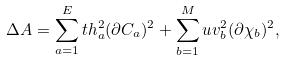Convert formula to latex. <formula><loc_0><loc_0><loc_500><loc_500>\Delta A = \sum _ { a = 1 } ^ { E } t h _ { a } ^ { 2 } ( \partial C _ { a } ) ^ { 2 } + \sum _ { b = 1 } ^ { M } u v _ { b } ^ { 2 } ( \partial \chi _ { b } ) ^ { 2 } ,</formula> 